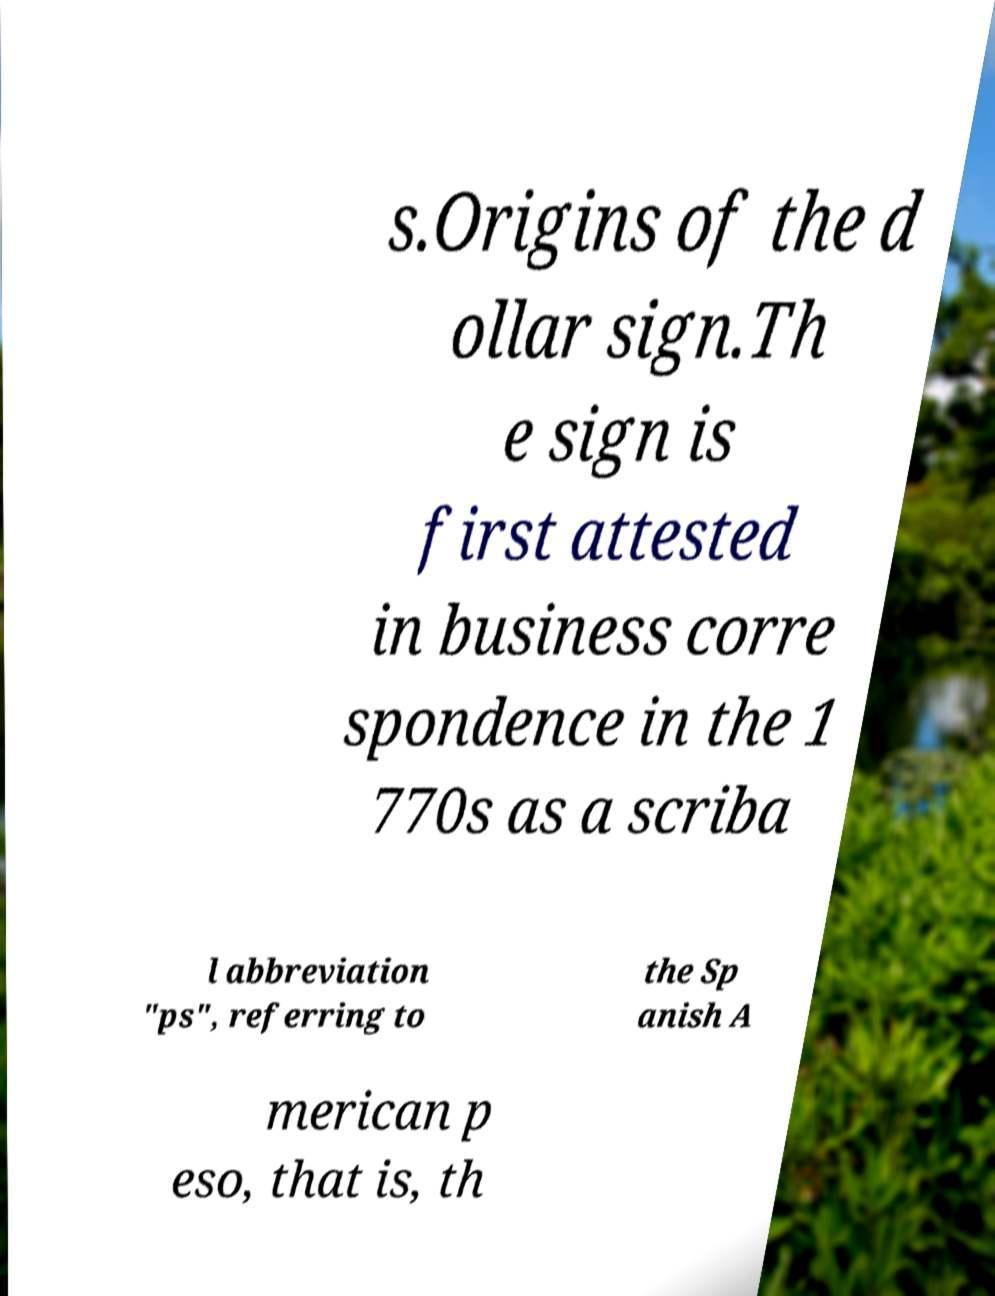For documentation purposes, I need the text within this image transcribed. Could you provide that? s.Origins of the d ollar sign.Th e sign is first attested in business corre spondence in the 1 770s as a scriba l abbreviation "ps", referring to the Sp anish A merican p eso, that is, th 